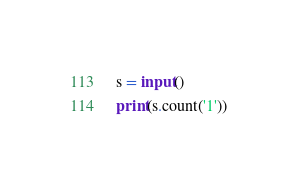Convert code to text. <code><loc_0><loc_0><loc_500><loc_500><_Python_>s = input()
print(s.count('1'))</code> 